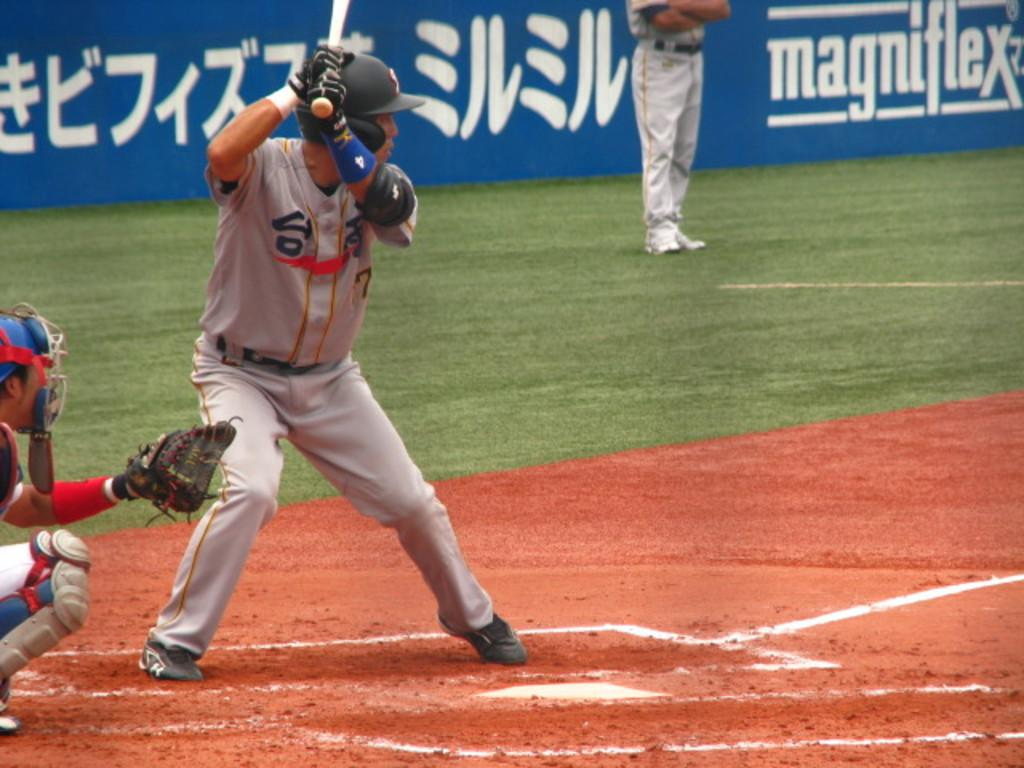<image>
Share a concise interpretation of the image provided. A ball player on a field sponsored by MAGNIGLEX. 